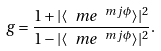<formula> <loc_0><loc_0><loc_500><loc_500>g = \frac { 1 + | \langle \ m e ^ { \ m j \phi } \rangle | ^ { 2 } } { 1 - | \langle \ m e ^ { \ m j \phi } \rangle | ^ { 2 } } .</formula> 